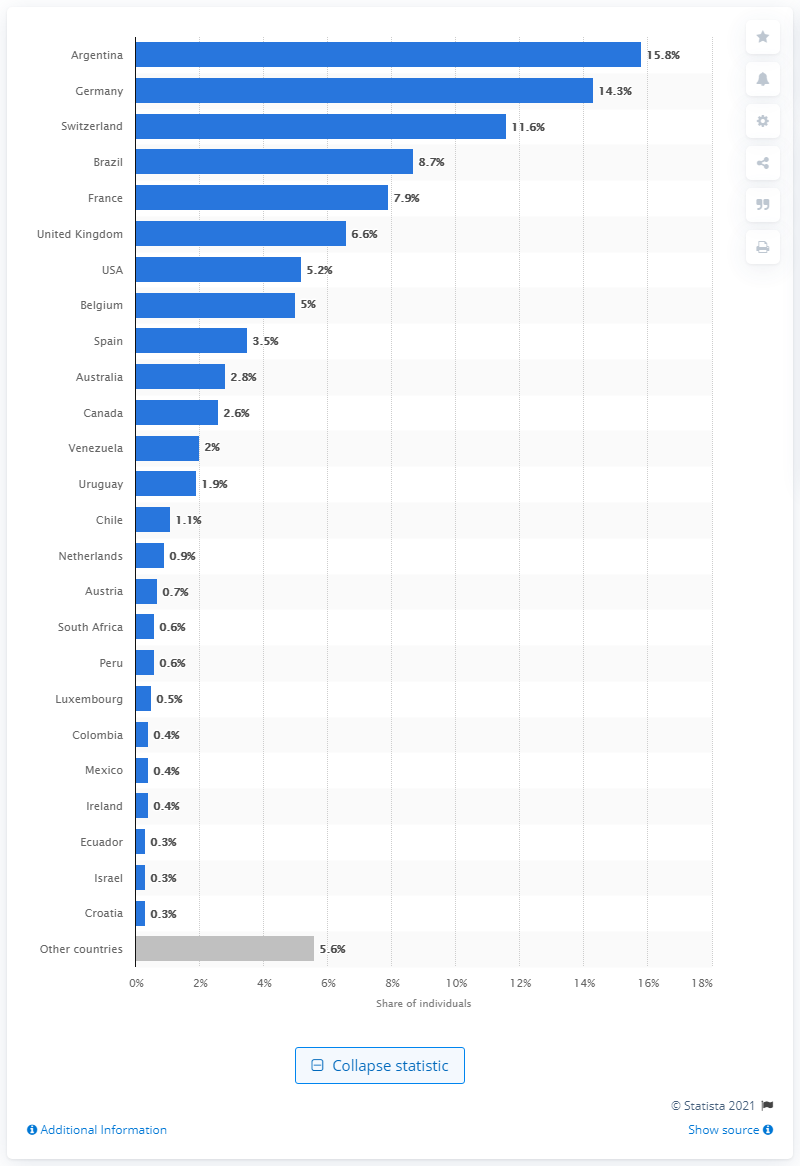Indicate a few pertinent items in this graphic. The primary destination country for Italian migrants was Argentina. The second largest number of Italians living abroad came from Germany. 